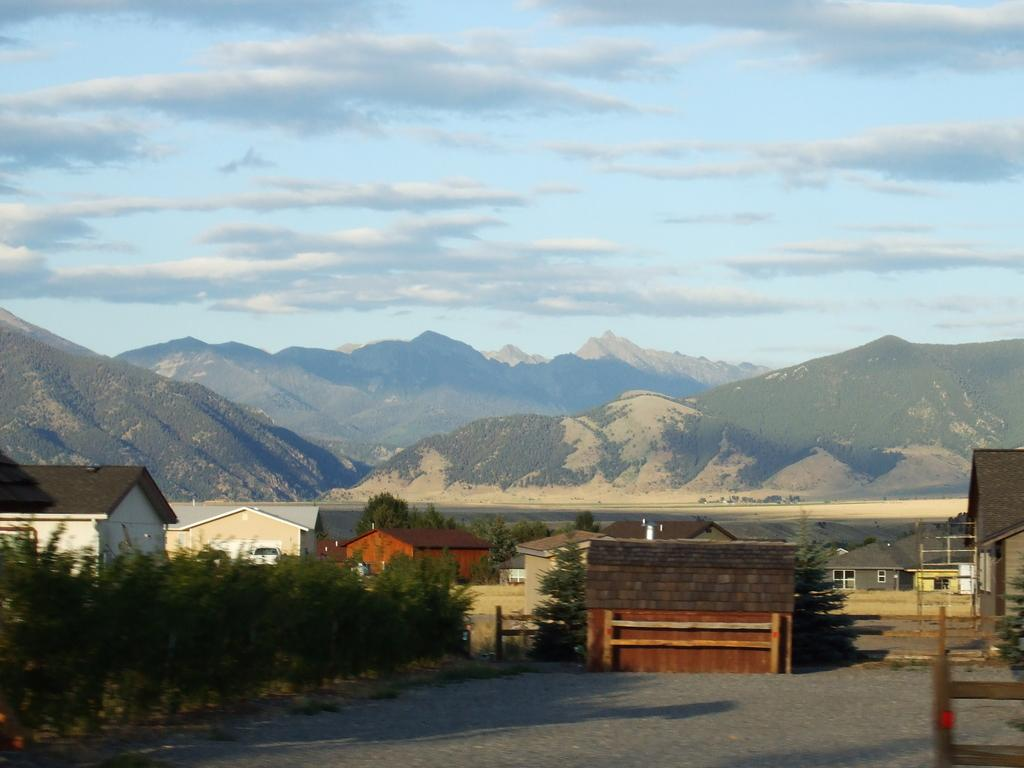What can be seen in the foreground of the image? There are houses and trees in the foreground of the image. What is located in the background of the image? There are mountains and the sky in the background of the image. What type of boats can be seen in the harbor in the image? There is no harbor present in the image; it features houses, trees, mountains, and the sky. What month is it in the image? The month cannot be determined from the image, as there is no specific information about the time of year. 